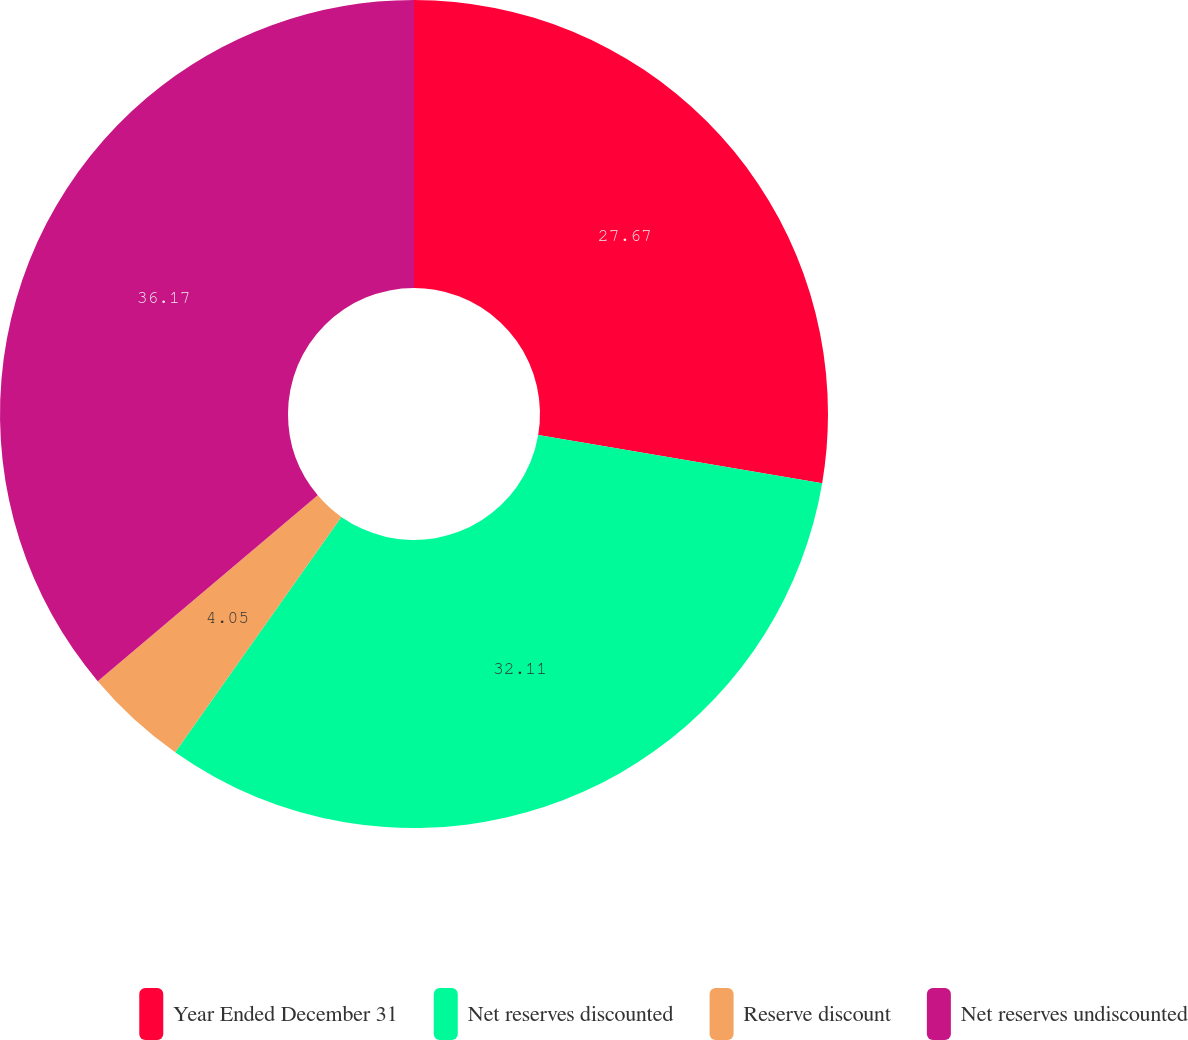<chart> <loc_0><loc_0><loc_500><loc_500><pie_chart><fcel>Year Ended December 31<fcel>Net reserves discounted<fcel>Reserve discount<fcel>Net reserves undiscounted<nl><fcel>27.67%<fcel>32.11%<fcel>4.05%<fcel>36.16%<nl></chart> 